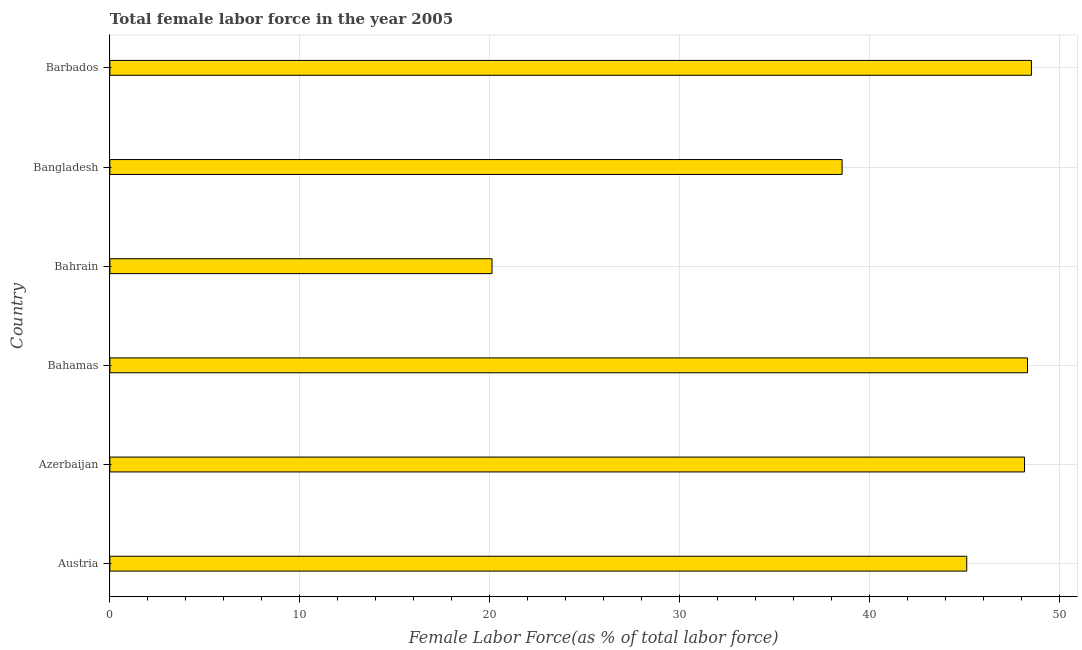Does the graph contain any zero values?
Your answer should be very brief. No. What is the title of the graph?
Provide a succinct answer. Total female labor force in the year 2005. What is the label or title of the X-axis?
Keep it short and to the point. Female Labor Force(as % of total labor force). What is the total female labor force in Bahamas?
Your answer should be very brief. 48.32. Across all countries, what is the maximum total female labor force?
Ensure brevity in your answer.  48.53. Across all countries, what is the minimum total female labor force?
Offer a terse response. 20.12. In which country was the total female labor force maximum?
Keep it short and to the point. Barbados. In which country was the total female labor force minimum?
Make the answer very short. Bahrain. What is the sum of the total female labor force?
Give a very brief answer. 248.82. What is the difference between the total female labor force in Bahamas and Barbados?
Ensure brevity in your answer.  -0.21. What is the average total female labor force per country?
Offer a very short reply. 41.47. What is the median total female labor force?
Offer a terse response. 46.64. What is the ratio of the total female labor force in Austria to that in Bahrain?
Make the answer very short. 2.24. Is the difference between the total female labor force in Bahamas and Barbados greater than the difference between any two countries?
Your response must be concise. No. What is the difference between the highest and the second highest total female labor force?
Provide a succinct answer. 0.21. Is the sum of the total female labor force in Austria and Bangladesh greater than the maximum total female labor force across all countries?
Give a very brief answer. Yes. What is the difference between the highest and the lowest total female labor force?
Your answer should be very brief. 28.41. In how many countries, is the total female labor force greater than the average total female labor force taken over all countries?
Provide a short and direct response. 4. How many countries are there in the graph?
Your answer should be very brief. 6. What is the difference between two consecutive major ticks on the X-axis?
Make the answer very short. 10. Are the values on the major ticks of X-axis written in scientific E-notation?
Your response must be concise. No. What is the Female Labor Force(as % of total labor force) in Austria?
Provide a short and direct response. 45.12. What is the Female Labor Force(as % of total labor force) in Azerbaijan?
Provide a short and direct response. 48.16. What is the Female Labor Force(as % of total labor force) of Bahamas?
Your answer should be compact. 48.32. What is the Female Labor Force(as % of total labor force) of Bahrain?
Your answer should be very brief. 20.12. What is the Female Labor Force(as % of total labor force) in Bangladesh?
Offer a very short reply. 38.56. What is the Female Labor Force(as % of total labor force) of Barbados?
Provide a succinct answer. 48.53. What is the difference between the Female Labor Force(as % of total labor force) in Austria and Azerbaijan?
Offer a terse response. -3.04. What is the difference between the Female Labor Force(as % of total labor force) in Austria and Bahamas?
Your response must be concise. -3.2. What is the difference between the Female Labor Force(as % of total labor force) in Austria and Bahrain?
Your answer should be very brief. 25. What is the difference between the Female Labor Force(as % of total labor force) in Austria and Bangladesh?
Provide a short and direct response. 6.56. What is the difference between the Female Labor Force(as % of total labor force) in Austria and Barbados?
Give a very brief answer. -3.41. What is the difference between the Female Labor Force(as % of total labor force) in Azerbaijan and Bahamas?
Make the answer very short. -0.16. What is the difference between the Female Labor Force(as % of total labor force) in Azerbaijan and Bahrain?
Your answer should be very brief. 28.04. What is the difference between the Female Labor Force(as % of total labor force) in Azerbaijan and Bangladesh?
Your answer should be compact. 9.61. What is the difference between the Female Labor Force(as % of total labor force) in Azerbaijan and Barbados?
Provide a succinct answer. -0.36. What is the difference between the Female Labor Force(as % of total labor force) in Bahamas and Bahrain?
Ensure brevity in your answer.  28.2. What is the difference between the Female Labor Force(as % of total labor force) in Bahamas and Bangladesh?
Provide a short and direct response. 9.76. What is the difference between the Female Labor Force(as % of total labor force) in Bahamas and Barbados?
Your response must be concise. -0.21. What is the difference between the Female Labor Force(as % of total labor force) in Bahrain and Bangladesh?
Provide a short and direct response. -18.44. What is the difference between the Female Labor Force(as % of total labor force) in Bahrain and Barbados?
Your answer should be compact. -28.41. What is the difference between the Female Labor Force(as % of total labor force) in Bangladesh and Barbados?
Your answer should be compact. -9.97. What is the ratio of the Female Labor Force(as % of total labor force) in Austria to that in Azerbaijan?
Your answer should be very brief. 0.94. What is the ratio of the Female Labor Force(as % of total labor force) in Austria to that in Bahamas?
Ensure brevity in your answer.  0.93. What is the ratio of the Female Labor Force(as % of total labor force) in Austria to that in Bahrain?
Offer a very short reply. 2.24. What is the ratio of the Female Labor Force(as % of total labor force) in Austria to that in Bangladesh?
Your answer should be very brief. 1.17. What is the ratio of the Female Labor Force(as % of total labor force) in Austria to that in Barbados?
Offer a terse response. 0.93. What is the ratio of the Female Labor Force(as % of total labor force) in Azerbaijan to that in Bahamas?
Provide a short and direct response. 1. What is the ratio of the Female Labor Force(as % of total labor force) in Azerbaijan to that in Bahrain?
Ensure brevity in your answer.  2.39. What is the ratio of the Female Labor Force(as % of total labor force) in Azerbaijan to that in Bangladesh?
Your response must be concise. 1.25. What is the ratio of the Female Labor Force(as % of total labor force) in Bahamas to that in Bahrain?
Your answer should be compact. 2.4. What is the ratio of the Female Labor Force(as % of total labor force) in Bahamas to that in Bangladesh?
Keep it short and to the point. 1.25. What is the ratio of the Female Labor Force(as % of total labor force) in Bahamas to that in Barbados?
Your answer should be compact. 1. What is the ratio of the Female Labor Force(as % of total labor force) in Bahrain to that in Bangladesh?
Provide a succinct answer. 0.52. What is the ratio of the Female Labor Force(as % of total labor force) in Bahrain to that in Barbados?
Ensure brevity in your answer.  0.41. What is the ratio of the Female Labor Force(as % of total labor force) in Bangladesh to that in Barbados?
Give a very brief answer. 0.8. 